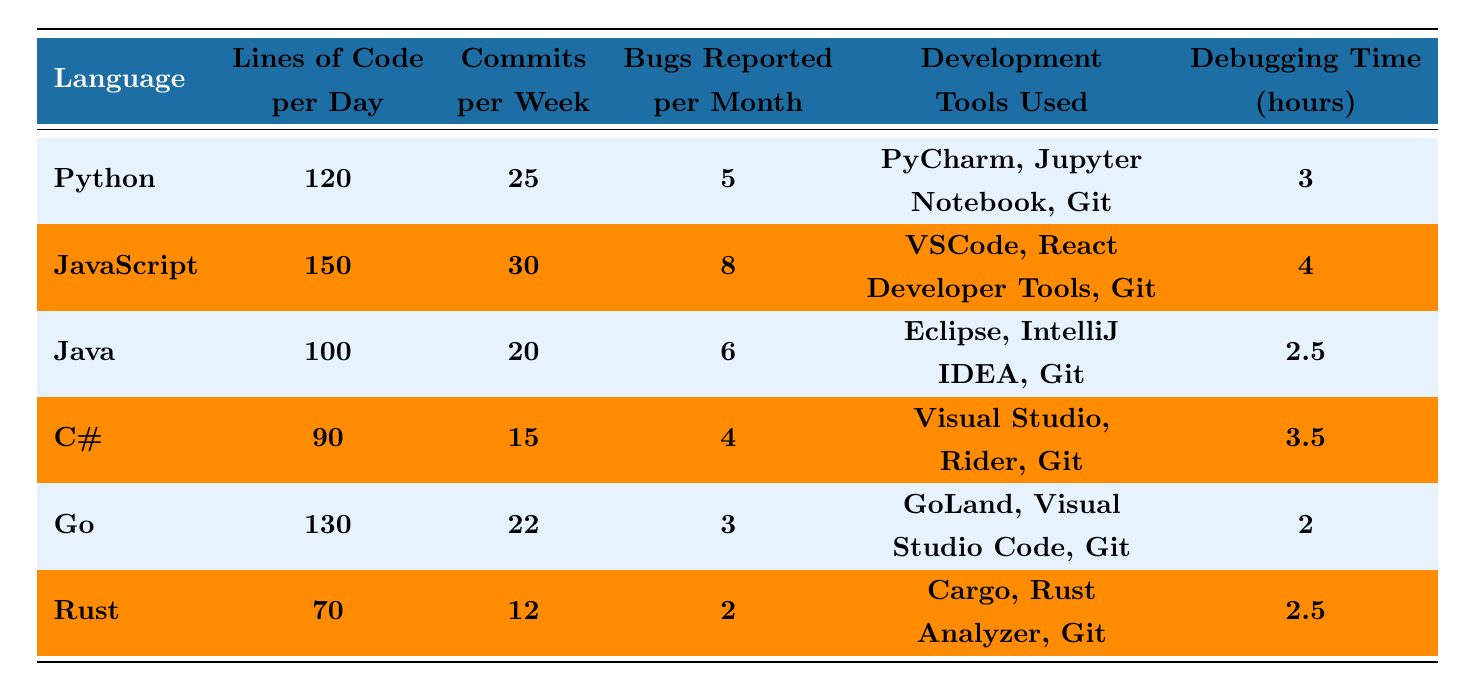What is the average number of lines of code per day written in Java? The table indicates that the average lines of code per day for Java is explicitly mentioned as 100.
Answer: 100 Which programming language has the highest number of commits per week? By comparing the commits per week across all languages, JavaScript shows the highest value at 30.
Answer: JavaScript How many bugs are reported per month on average in Go? The table directly states that Go has an average of 3 bugs reported per month.
Answer: 3 What is the average debugging time in hours for C#? The entry for C# in the table shows an average debugging time of 3.5 hours.
Answer: 3.5 Which programming language has the lowest average lines of code per day? Looking at the data, Rust has the lowest average lines of code per day at 70.
Answer: Rust If you sum the average lines of code per day for Python and Go, what do you get? Python averages 120 lines per day and Go averages 130 lines per day. Their sum is 120 + 130 = 250.
Answer: 250 Is it true that Java has fewer bugs reported per month than JavaScript? The table reveals that Java has 6 bugs reported per month, while JavaScript has 8. So, the statement is false.
Answer: No Which programming language uses the most development tools according to the table? The number of development tools is equal across all languages as each has three listed, so this question does not apply. However, each language has a consistent amount of tools.
Answer: None Calculate the average debugging time across all programming languages. The debugging times are 3, 4, 2.5, 3.5, 2, and 2.5 hours respectively, adding them gives 3 + 4 + 2.5 + 3.5 + 2 + 2.5 = 18. The average is 18/6 = 3.
Answer: 3 Which language has the highest ratio of bugs reported per commits made per week? First, we find the ratio for each language: Python: 5/25=0.2, JavaScript: 8/30=0.267, Java: 6/20=0.3, C#: 4/15=0.267, Go: 3/22=0.136, Rust: 2/12=0.167. The highest is Java at 0.3.
Answer: Java 